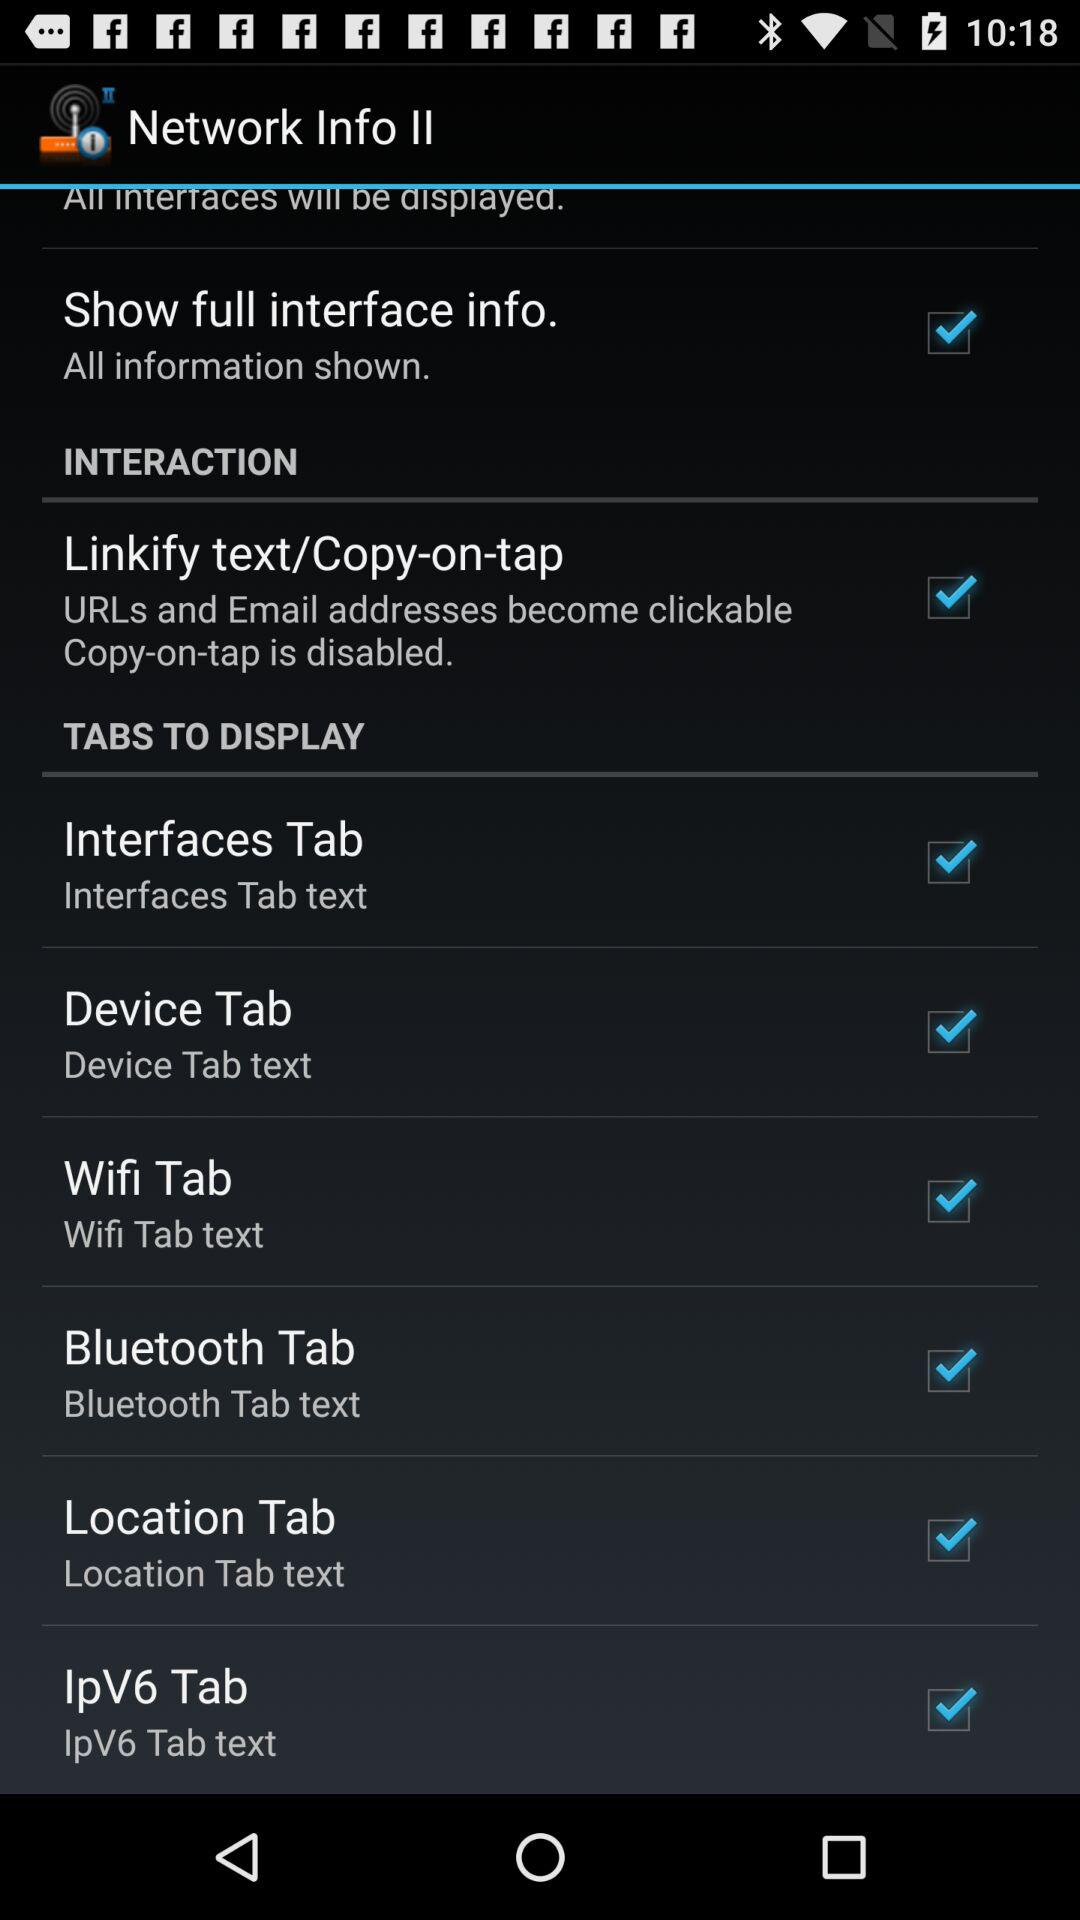What is the status of "Device Tab"? The status is "on". 